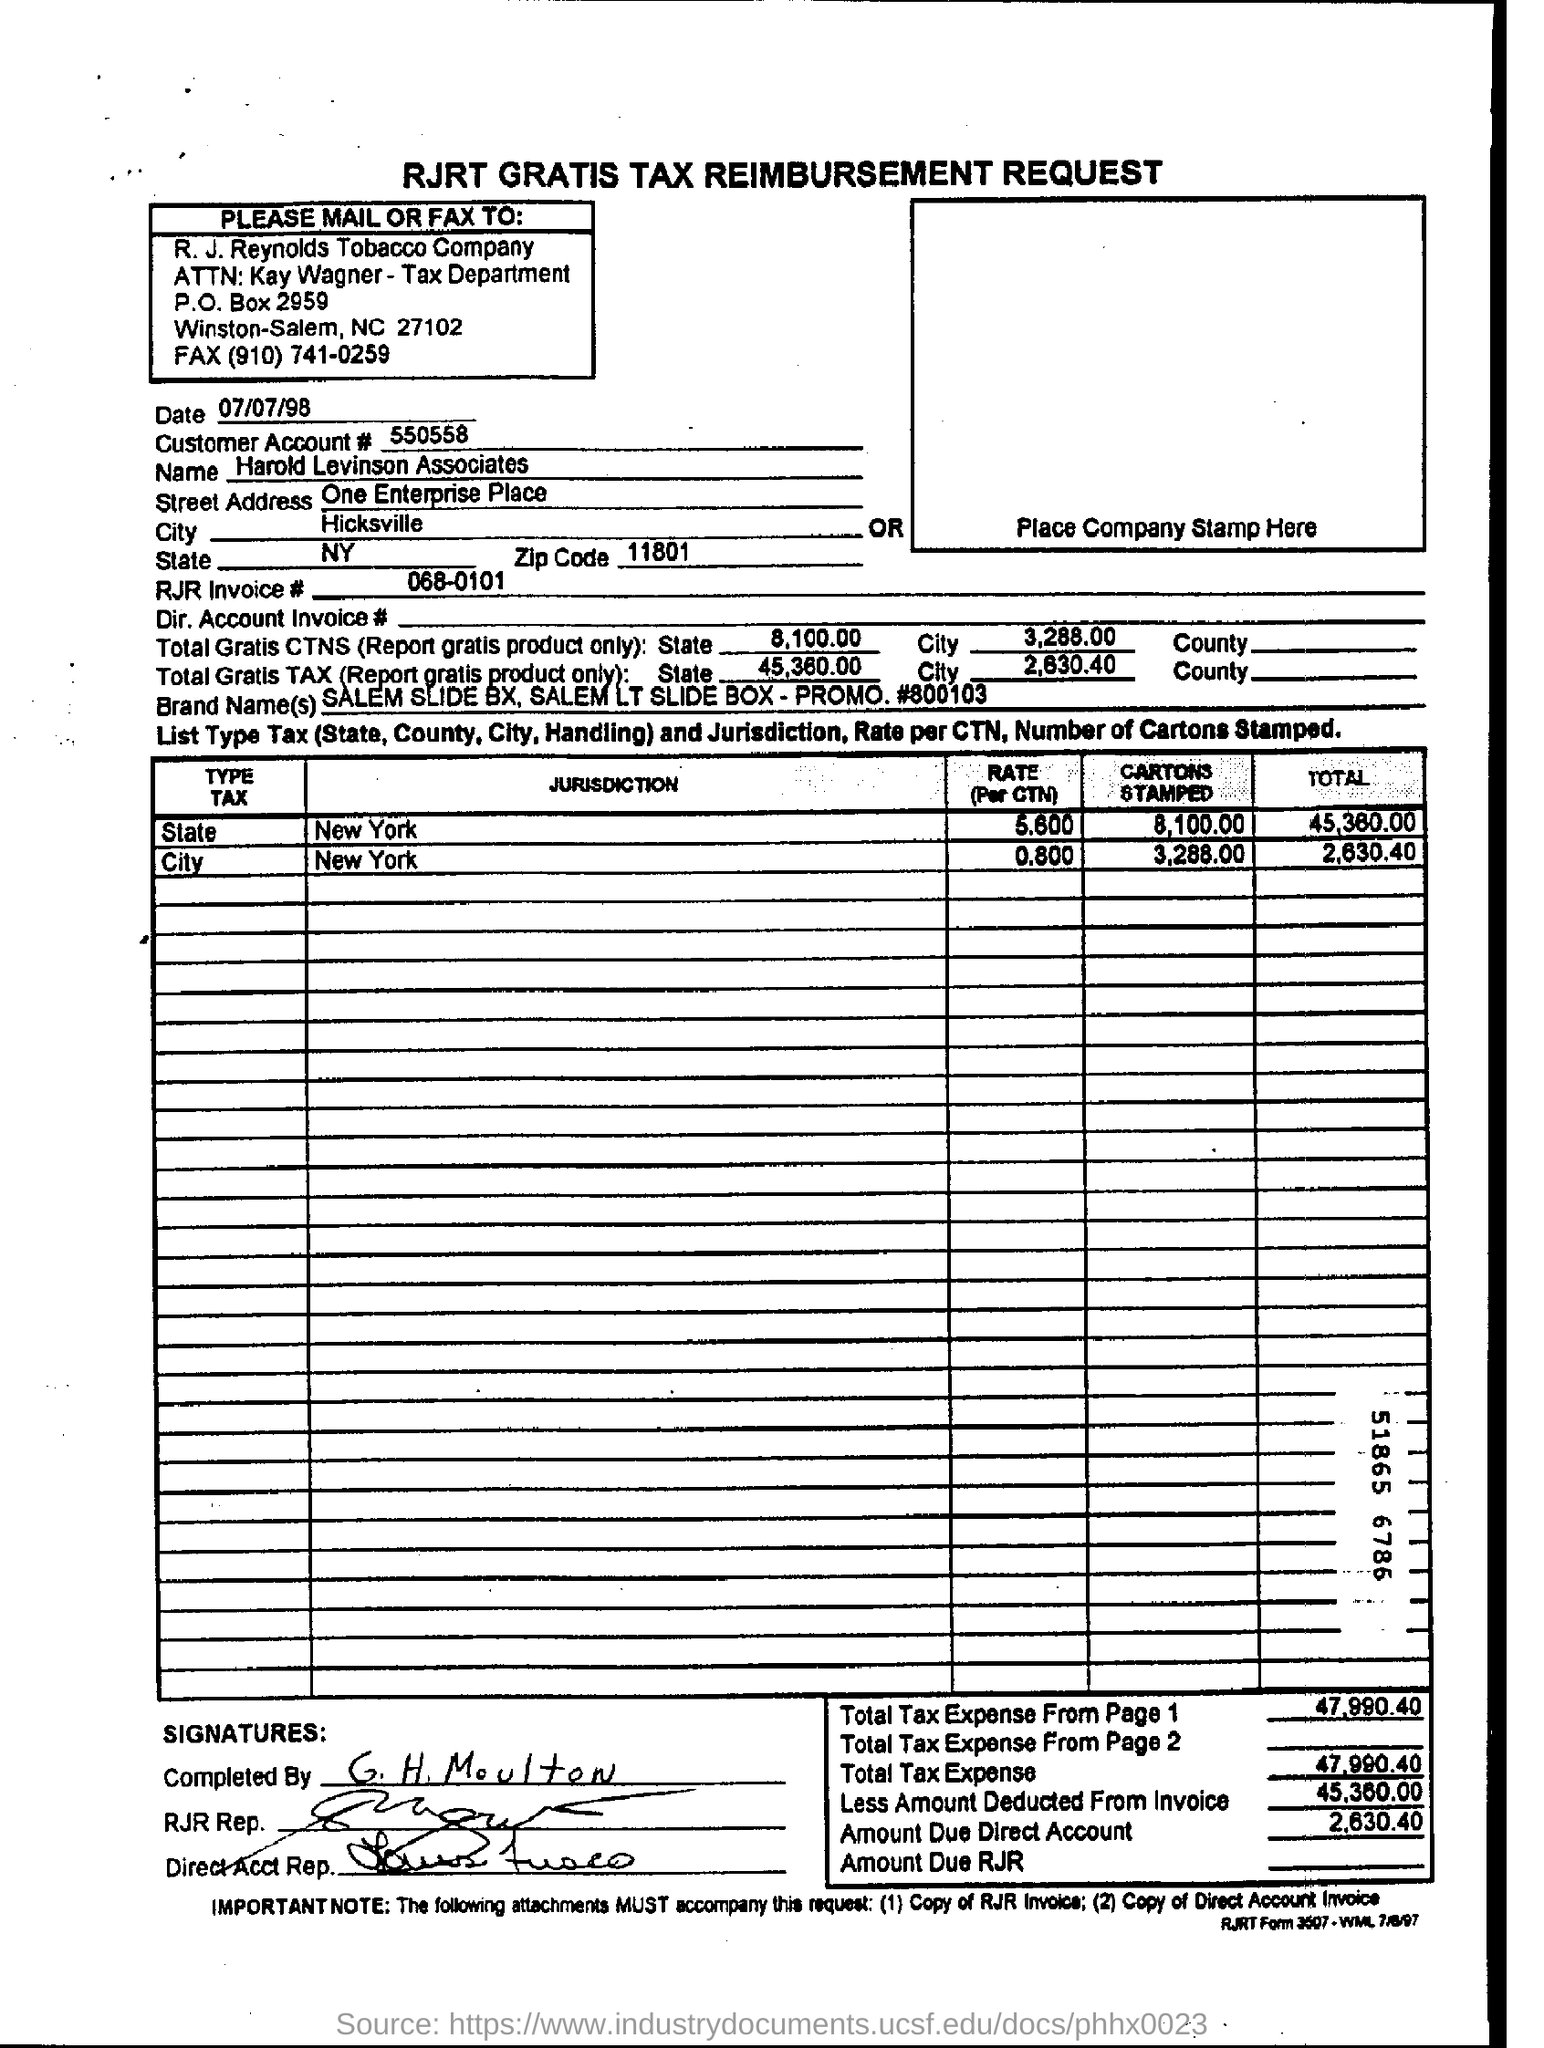What is the date mentioned ?
Provide a succinct answer. 07/07/98. What is the customer account# number ?
Your answer should be very brief. 550558. What is the name of the company entered in the form?
Offer a very short reply. Harold Levinson Associates. What is the rjr invoice# number ?
Make the answer very short. 068-0101. 